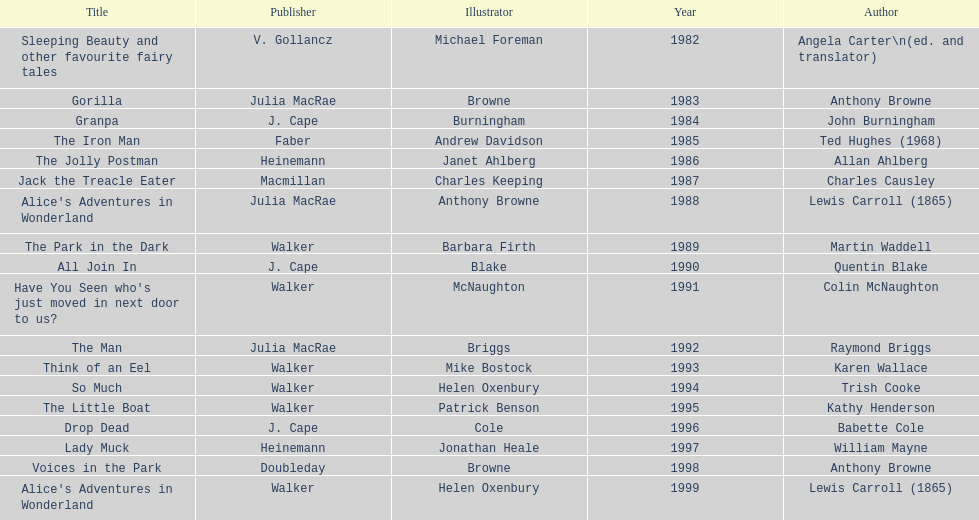Could you parse the entire table as a dict? {'header': ['Title', 'Publisher', 'Illustrator', 'Year', 'Author'], 'rows': [['Sleeping Beauty and other favourite fairy tales', 'V. Gollancz', 'Michael Foreman', '1982', 'Angela Carter\\n(ed. and translator)'], ['Gorilla', 'Julia MacRae', 'Browne', '1983', 'Anthony Browne'], ['Granpa', 'J. Cape', 'Burningham', '1984', 'John Burningham'], ['The Iron Man', 'Faber', 'Andrew Davidson', '1985', 'Ted Hughes (1968)'], ['The Jolly Postman', 'Heinemann', 'Janet Ahlberg', '1986', 'Allan Ahlberg'], ['Jack the Treacle Eater', 'Macmillan', 'Charles Keeping', '1987', 'Charles Causley'], ["Alice's Adventures in Wonderland", 'Julia MacRae', 'Anthony Browne', '1988', 'Lewis Carroll (1865)'], ['The Park in the Dark', 'Walker', 'Barbara Firth', '1989', 'Martin Waddell'], ['All Join In', 'J. Cape', 'Blake', '1990', 'Quentin Blake'], ["Have You Seen who's just moved in next door to us?", 'Walker', 'McNaughton', '1991', 'Colin McNaughton'], ['The Man', 'Julia MacRae', 'Briggs', '1992', 'Raymond Briggs'], ['Think of an Eel', 'Walker', 'Mike Bostock', '1993', 'Karen Wallace'], ['So Much', 'Walker', 'Helen Oxenbury', '1994', 'Trish Cooke'], ['The Little Boat', 'Walker', 'Patrick Benson', '1995', 'Kathy Henderson'], ['Drop Dead', 'J. Cape', 'Cole', '1996', 'Babette Cole'], ['Lady Muck', 'Heinemann', 'Jonathan Heale', '1997', 'William Mayne'], ['Voices in the Park', 'Doubleday', 'Browne', '1998', 'Anthony Browne'], ["Alice's Adventures in Wonderland", 'Walker', 'Helen Oxenbury', '1999', 'Lewis Carroll (1865)']]} What are the number of kurt maschler awards helen oxenbury has won? 2. 